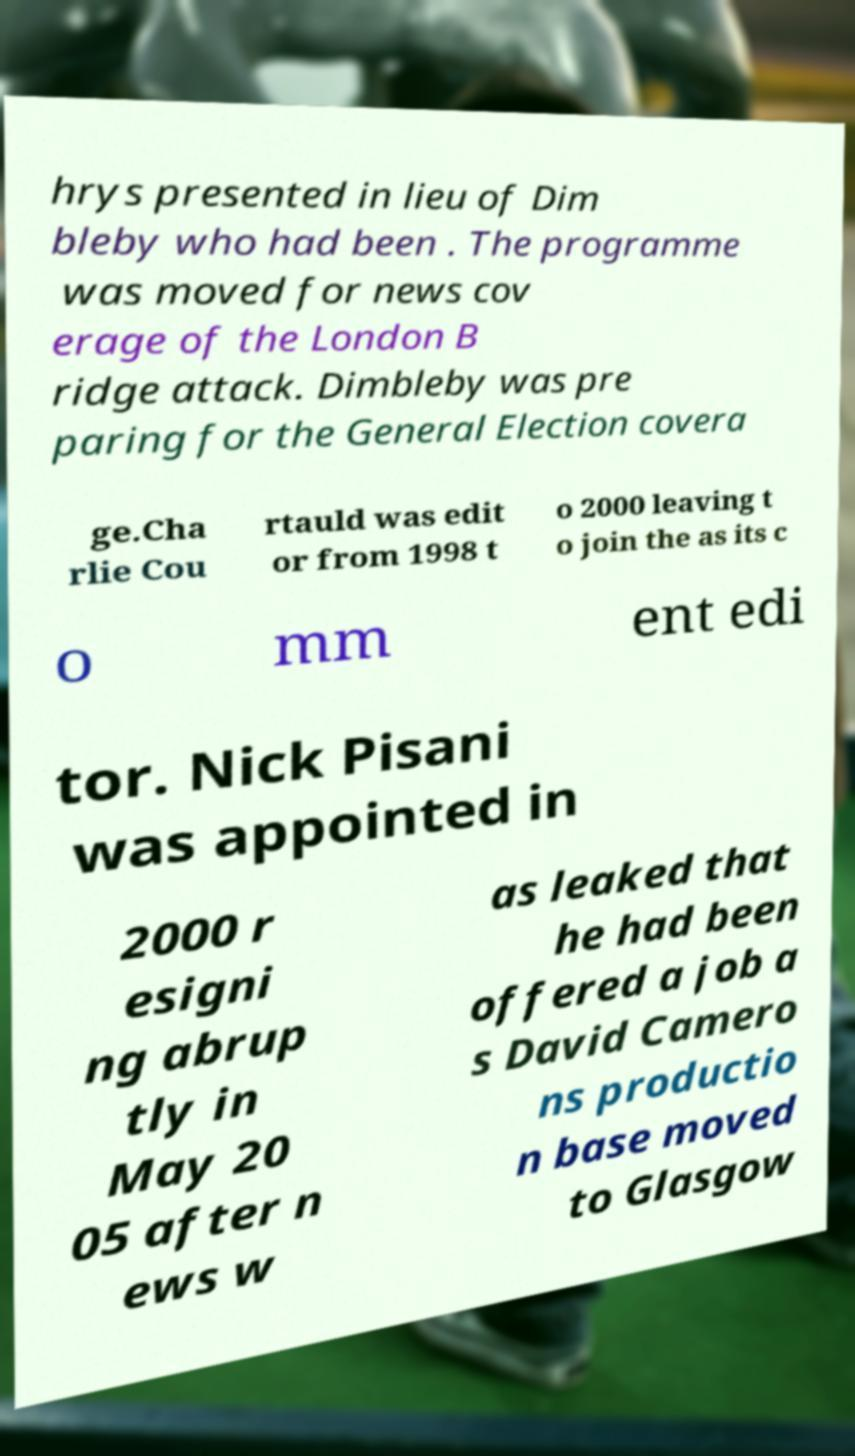Could you assist in decoding the text presented in this image and type it out clearly? hrys presented in lieu of Dim bleby who had been . The programme was moved for news cov erage of the London B ridge attack. Dimbleby was pre paring for the General Election covera ge.Cha rlie Cou rtauld was edit or from 1998 t o 2000 leaving t o join the as its c o mm ent edi tor. Nick Pisani was appointed in 2000 r esigni ng abrup tly in May 20 05 after n ews w as leaked that he had been offered a job a s David Camero ns productio n base moved to Glasgow 